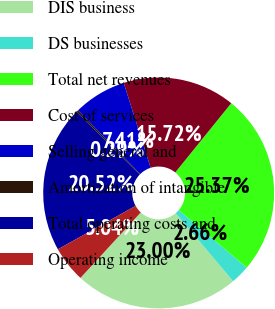Convert chart to OTSL. <chart><loc_0><loc_0><loc_500><loc_500><pie_chart><fcel>DIS business<fcel>DS businesses<fcel>Total net revenues<fcel>Cost of services<fcel>Selling general and<fcel>Amortization of intangible<fcel>Total operating costs and<fcel>Operating income<nl><fcel>23.0%<fcel>2.66%<fcel>25.37%<fcel>15.72%<fcel>7.41%<fcel>0.29%<fcel>20.52%<fcel>5.04%<nl></chart> 